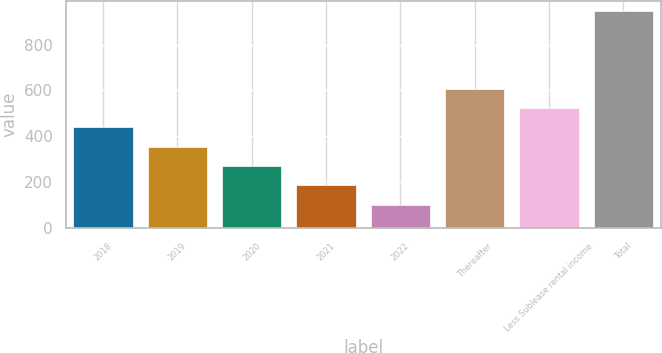Convert chart. <chart><loc_0><loc_0><loc_500><loc_500><bar_chart><fcel>2018<fcel>2019<fcel>2020<fcel>2021<fcel>2022<fcel>Thereafter<fcel>Less Sublease rental income<fcel>Total<nl><fcel>439.4<fcel>355.3<fcel>271.2<fcel>187.1<fcel>103<fcel>607.6<fcel>523.5<fcel>944<nl></chart> 